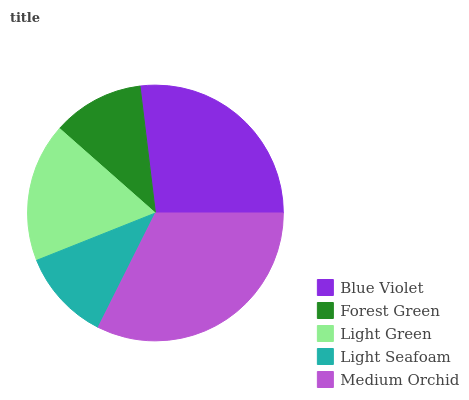Is Light Seafoam the minimum?
Answer yes or no. Yes. Is Medium Orchid the maximum?
Answer yes or no. Yes. Is Forest Green the minimum?
Answer yes or no. No. Is Forest Green the maximum?
Answer yes or no. No. Is Blue Violet greater than Forest Green?
Answer yes or no. Yes. Is Forest Green less than Blue Violet?
Answer yes or no. Yes. Is Forest Green greater than Blue Violet?
Answer yes or no. No. Is Blue Violet less than Forest Green?
Answer yes or no. No. Is Light Green the high median?
Answer yes or no. Yes. Is Light Green the low median?
Answer yes or no. Yes. Is Medium Orchid the high median?
Answer yes or no. No. Is Blue Violet the low median?
Answer yes or no. No. 